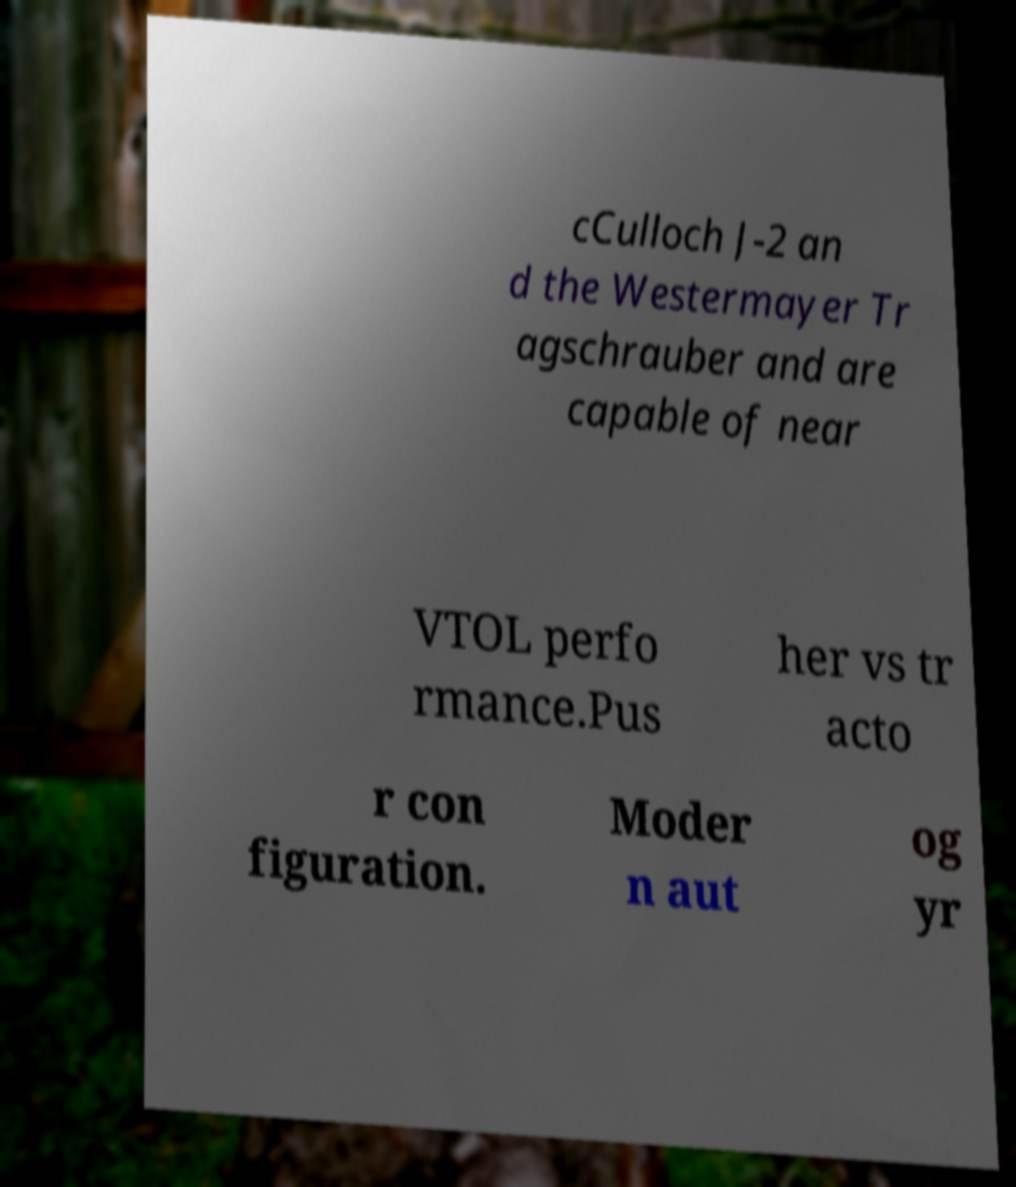For documentation purposes, I need the text within this image transcribed. Could you provide that? cCulloch J-2 an d the Westermayer Tr agschrauber and are capable of near VTOL perfo rmance.Pus her vs tr acto r con figuration. Moder n aut og yr 